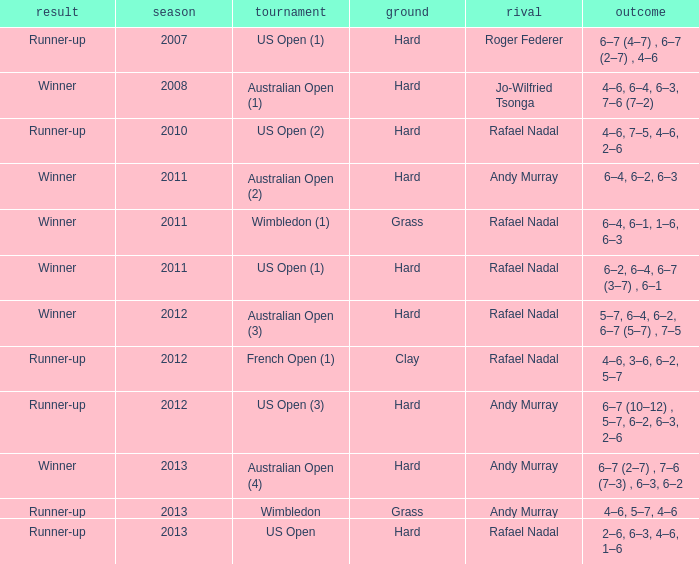What surface was the Australian Open (1) played on? Hard. 